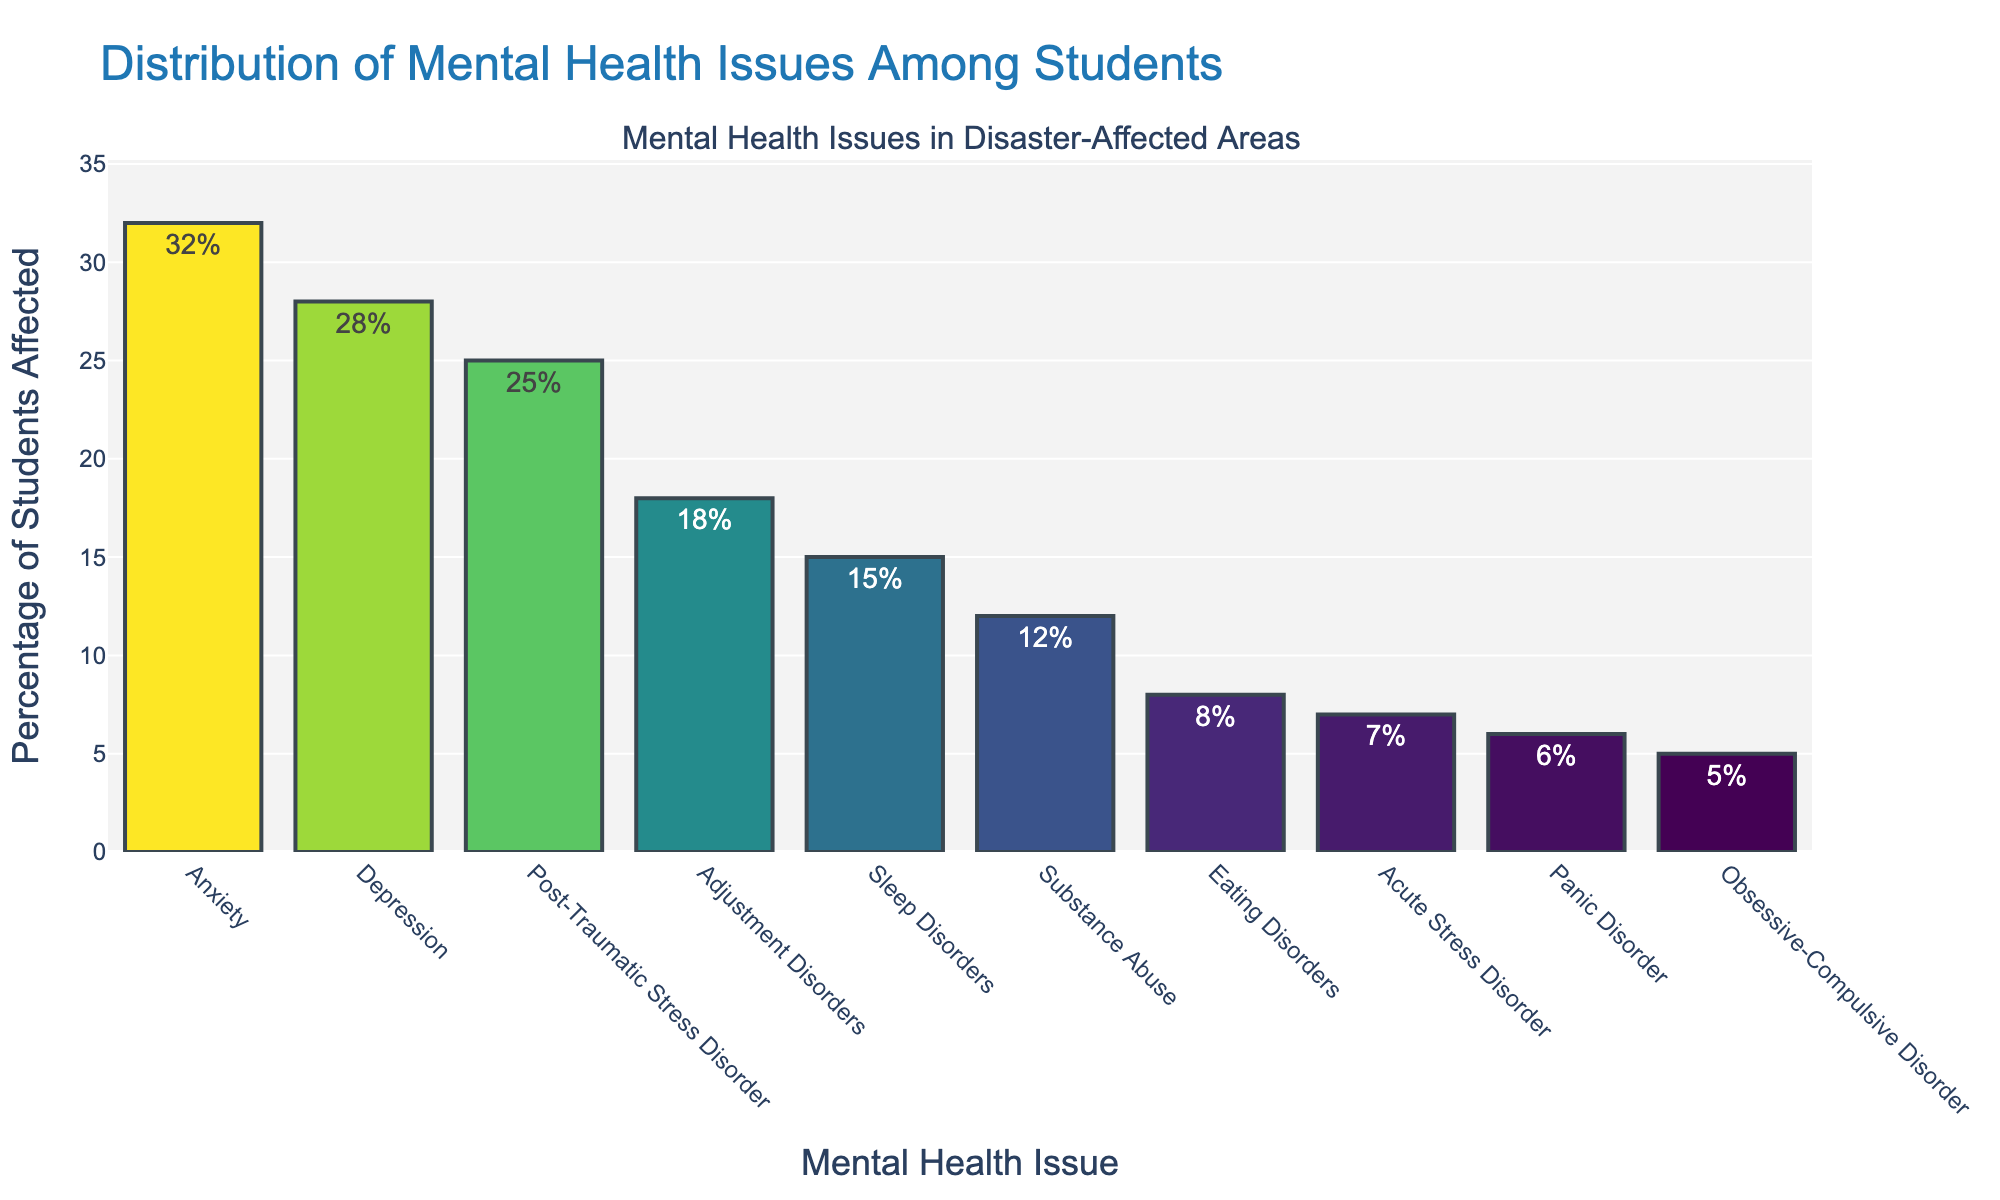Which mental health issue has the highest percentage among students in disaster-affected areas? The highest percentage can be identified by finding the tallest bar on the chart. The tallest bar represents Anxiety with a height of 32%.
Answer: Anxiety Which two mental health issues have the closest percentages? By examining the heights of the bars, the two bars that are closest in height are those for Adjustment Disorders (18%) and Sleep Disorders (15%), with a difference of 3%.
Answer: Adjustment Disorders and Sleep Disorders What is the total percentage of students affected by Depression and Post-Traumatic Stress Disorder combined? To find the total percentage, sum the percentages for Depression and Post-Traumatic Stress Disorder: 28% + 25% = 53%.
Answer: 53% How many mental health issues have a percentage greater than 20%? By checking each bar, the mental health issues with percentages more than 20% are Anxiety (32%), Depression (28%), and Post-Traumatic Stress Disorder (25%). There are three in total.
Answer: 3 Is the percentage of students affected by Eating Disorders more or less than one-third of those affected by Anxiety? One-third of Anxiety's percentage is 32% / 3 ≈ 10.67%. The percentage for Eating Disorders is 8%, which is less.
Answer: Less What is the percentage difference between the highest and lowest mental health issues? The highest percentage is Anxiety (32%) and the lowest is Obsessive-Compulsive Disorder (5%). The difference is 32% - 5% = 27%.
Answer: 27% How does the percentage of students affected by Panic Disorder compare to those affected by Acute Stress Disorder? Compare the heights of the bars for Panic Disorder (6%) and Acute Stress Disorder (7%). Panic Disorder is 1% lower.
Answer: Panic Disorder is 1% lower What is half of the percentage of students who experience Substance Abuse? The percentage for Substance Abuse is 12%. Half of this is 12% / 2 = 6%.
Answer: 6% Which mental health issue's bar color is the darkest shade and why might that be? The darkest shade likely corresponds to the highest percentage, which is Anxiety at 32%. Darker bars often represent higher values in a color gradient.
Answer: Anxiety If you were to average the percentages of the three least common mental health issues, what would that be? The three least common mental health issues are Panic Disorder (6%), Obsessive-Compulsive Disorder (5%), and Acute Stress Disorder (7%). The average is (6% + 5% + 7%) / 3 = 6%.
Answer: 6% 